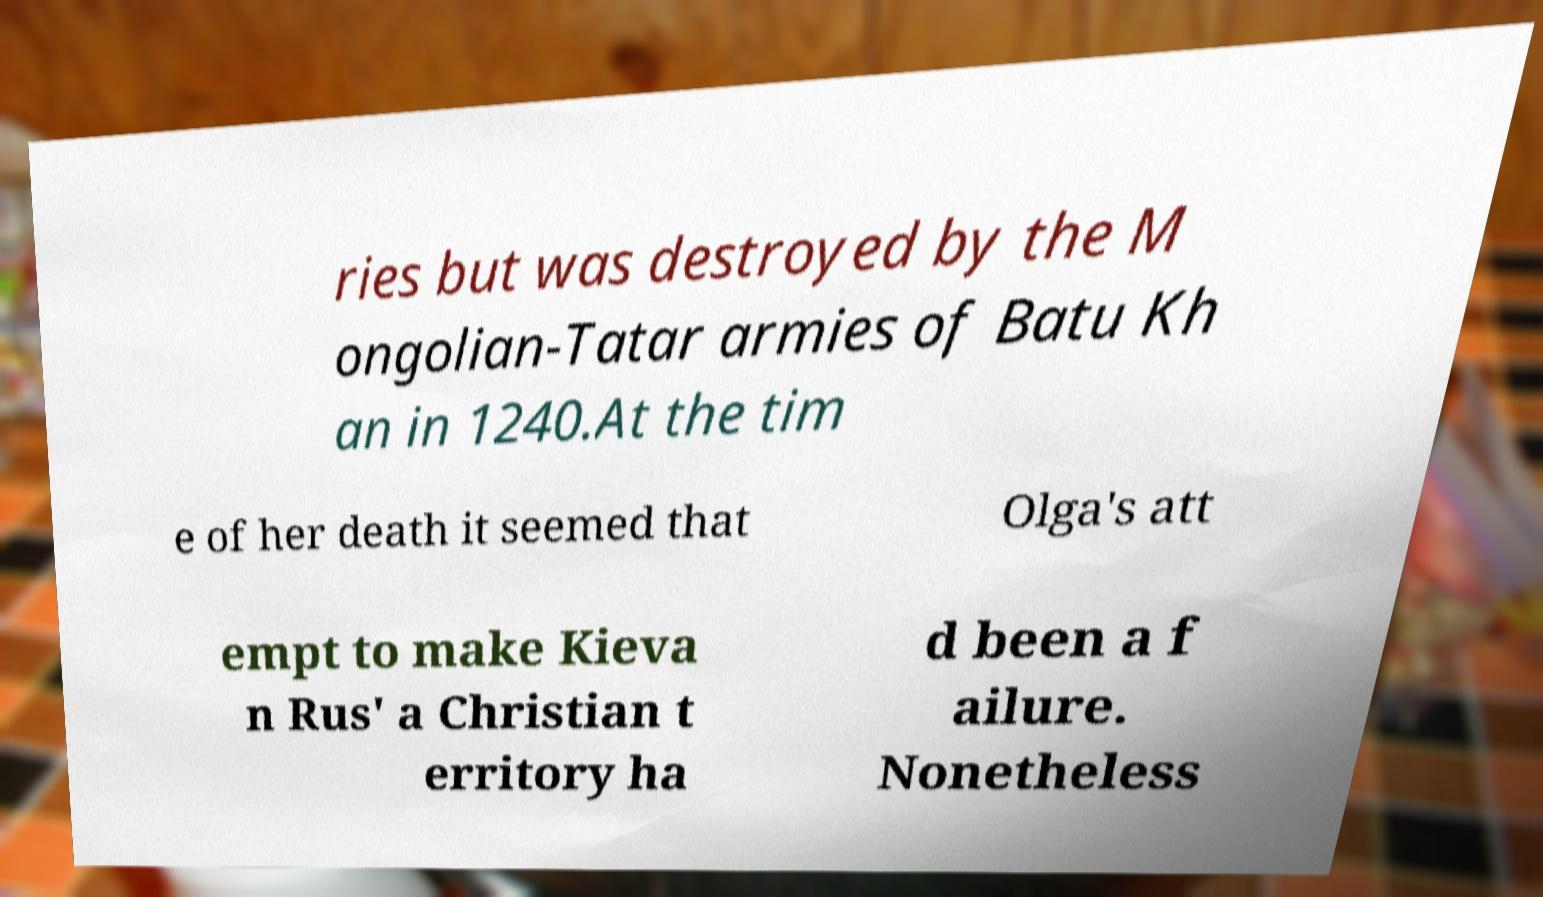Can you accurately transcribe the text from the provided image for me? ries but was destroyed by the M ongolian-Tatar armies of Batu Kh an in 1240.At the tim e of her death it seemed that Olga's att empt to make Kieva n Rus' a Christian t erritory ha d been a f ailure. Nonetheless 